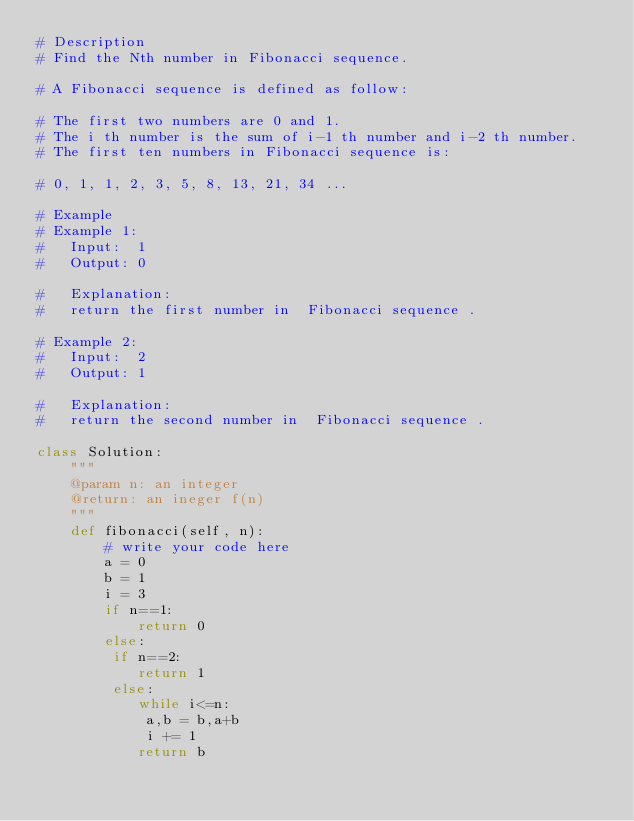<code> <loc_0><loc_0><loc_500><loc_500><_Python_># Description
# Find the Nth number in Fibonacci sequence.

# A Fibonacci sequence is defined as follow:

# The first two numbers are 0 and 1.
# The i th number is the sum of i-1 th number and i-2 th number.
# The first ten numbers in Fibonacci sequence is:

# 0, 1, 1, 2, 3, 5, 8, 13, 21, 34 ...

# Example
# Example 1:
# 	Input:  1
# 	Output: 0
	
# 	Explanation: 
# 	return the first number in  Fibonacci sequence .

# Example 2:
# 	Input:  2
# 	Output: 1
	
# 	Explanation: 
# 	return the second number in  Fibonacci sequence .

class Solution:
    """
    @param n: an integer
    @return: an ineger f(n)
    """
    def fibonacci(self, n):
        # write your code here
        a = 0
        b = 1
        i = 3
        if n==1:
            return 0
        else:
         if n==2:
            return 1
         else:
            while i<=n:
             a,b = b,a+b
             i += 1
            return b
</code> 